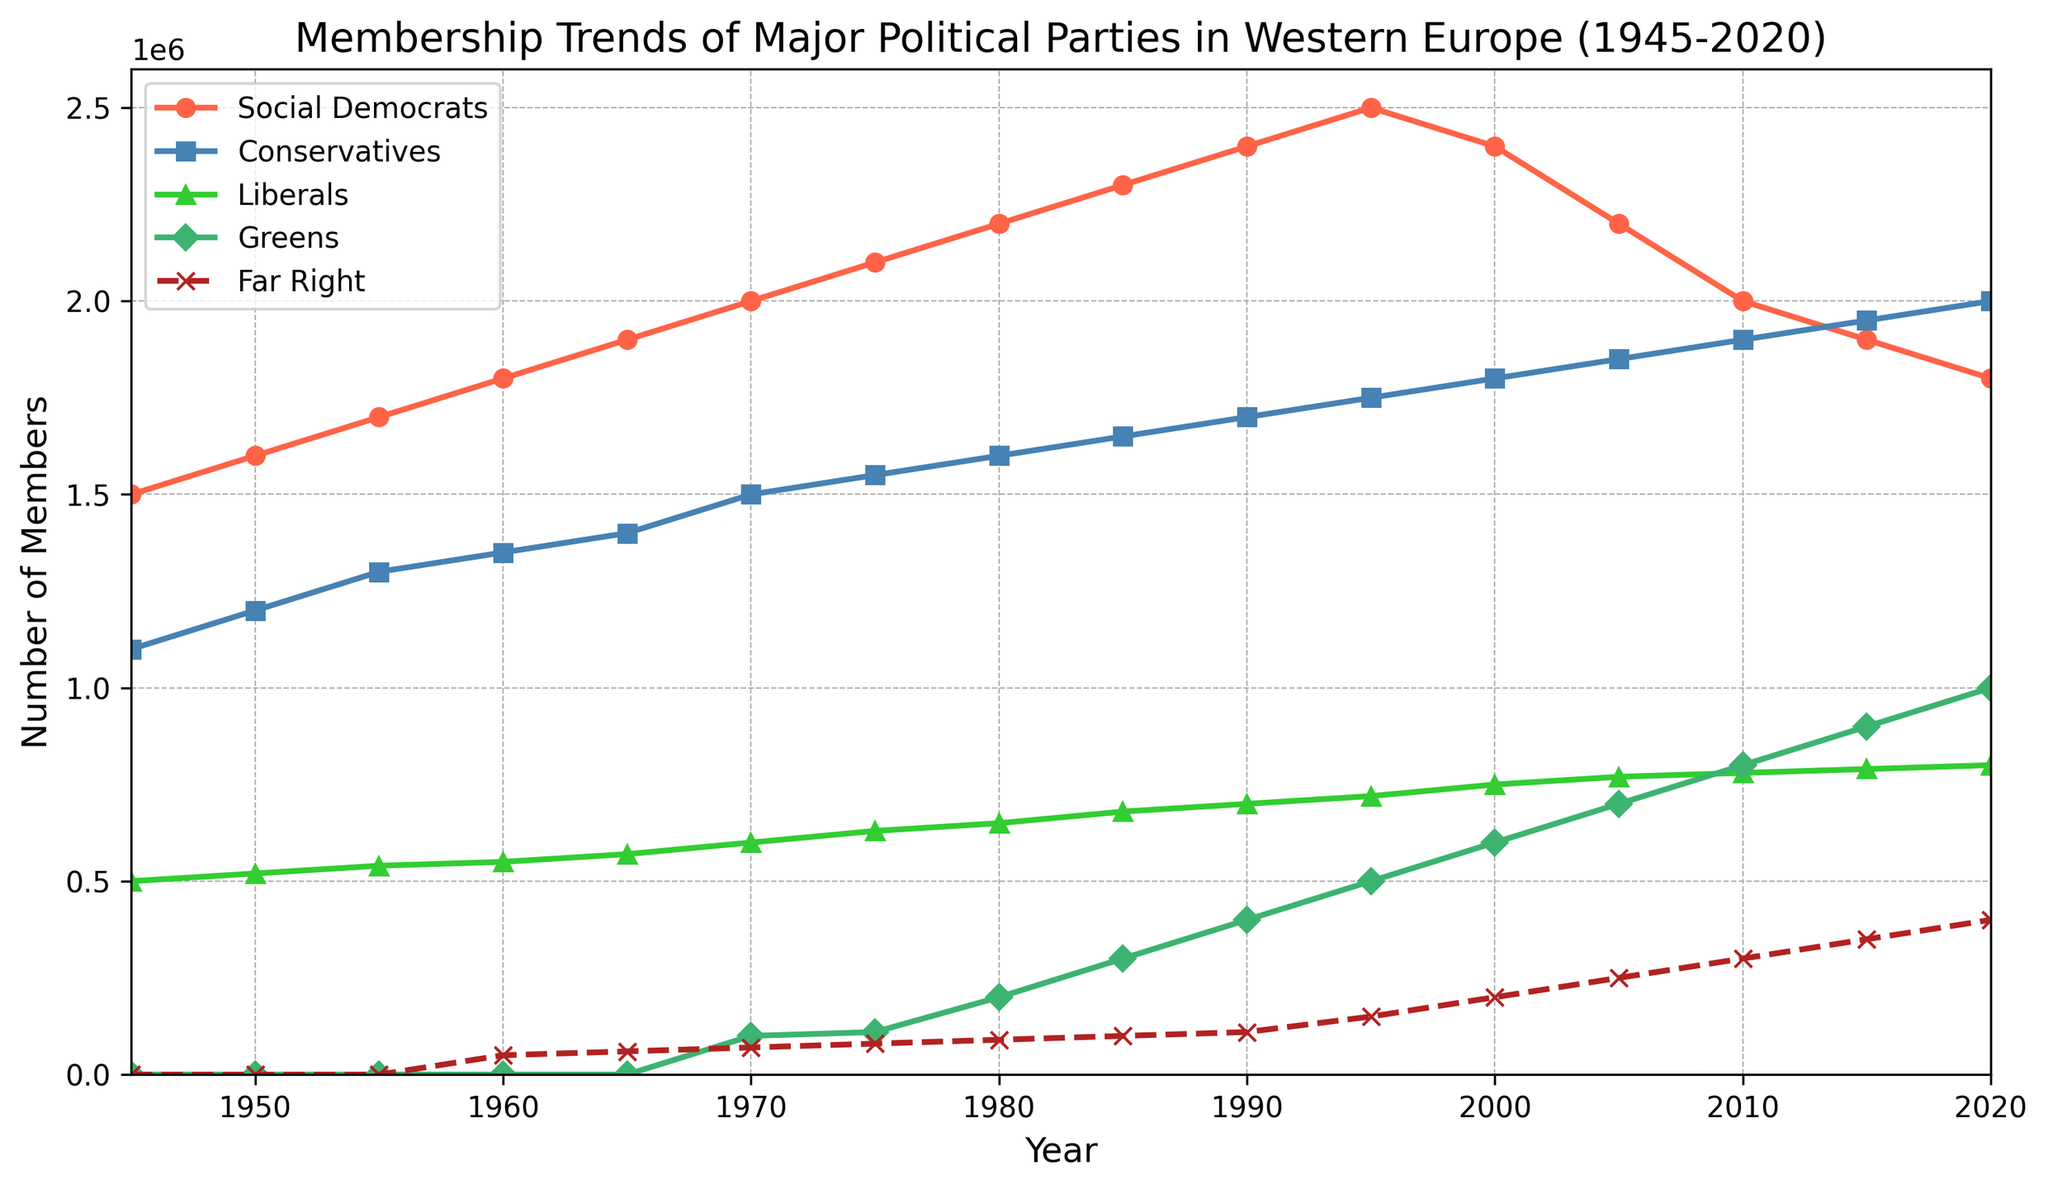What are the trends in membership for the Social Democrats and the Conservatives from 1945 to 2020? From 1945 to 2020, membership for the Social Democrats increased steadily from 1,500,000 to a peak of 2,500,000 in 1995, then gradually declined to 1,800,000 by 2020. The Conservatives also saw a steady increase from 1,100,000 in 1945 to 2,000,000 in 2020, with no peak but a consistent rise.
Answer: Social Democrats: Peak in 1995 and then decline, Conservatives: Steady increase Between which years did the Greens experience their most significant growth in membership? The Greens experienced their most significant growth between 1980 (when their membership was 200,000) and 2015 (when their membership reached 900,000). This period saw their membership increase significantly by 700,000 members.
Answer: 1980 to 2015 How does the membership trend of the Far Right compare to that of the Liberals from 1960 to 2020? The Far Right started with a low membership of 50,000 in 1960 and increased to 400,000 by 2020, showing a steady rise throughout the period. The Liberals started with 550,000 in 1960 and rose to 800,000 by 2020, also showing a steady increase but with a higher overall membership than the Far Right.
Answer: Far Right: Steady but lower increase, Liberals: Consistent and higher increase In what year did the Social Democrats and Conservatives have the same number of members? The Social Democrats and Conservatives had the same number of members in 2020, both reaching 2,000,000 members each.
Answer: 2020 What is the difference in membership between the Social Democrats and Greens in 2020? In 2020, the Social Democrats had 1,800,000 members compared to the Greens who had 1,000,000 members. The difference in their membership is 1,800,000 - 1,000,000 = 800,000.
Answer: 800,000 Which party had the highest growth rate between 1945 and 2020? The Greens had the highest growth rate between 1945 and 2020. They had 0 members in 1945, reaching 1,000,000 members by 2020.
Answer: Greens What was the membership trend of the Liberals between 2000 and 2020? The Liberals increased their membership from 750,000 in 2000 to 800,000 in 2020, showing a gradual growth of 50,000 over the two decades.
Answer: Gradual growth When did the Far Right first surpass the 100,000 membership mark? The Far Right first surpassed the 100,000 membership mark in 1985, when their membership reached 100,000.
Answer: 1985 Which party showed a decrease in membership after 1995? The Social Democrats is the only party that showed a decrease in membership after 1995, dropping from 2,500,000 in 1995 to 1,800,000 in 2020.
Answer: Social Democrats During which decades did the Social Democrats experience a drop in their membership numbers? The Social Democrats experienced a drop in their membership numbers during the 2000s and 2010s, decreasing from 2,500,000 in 1995 to 1,800,000 in 2020.
Answer: 2000s and 2010s 